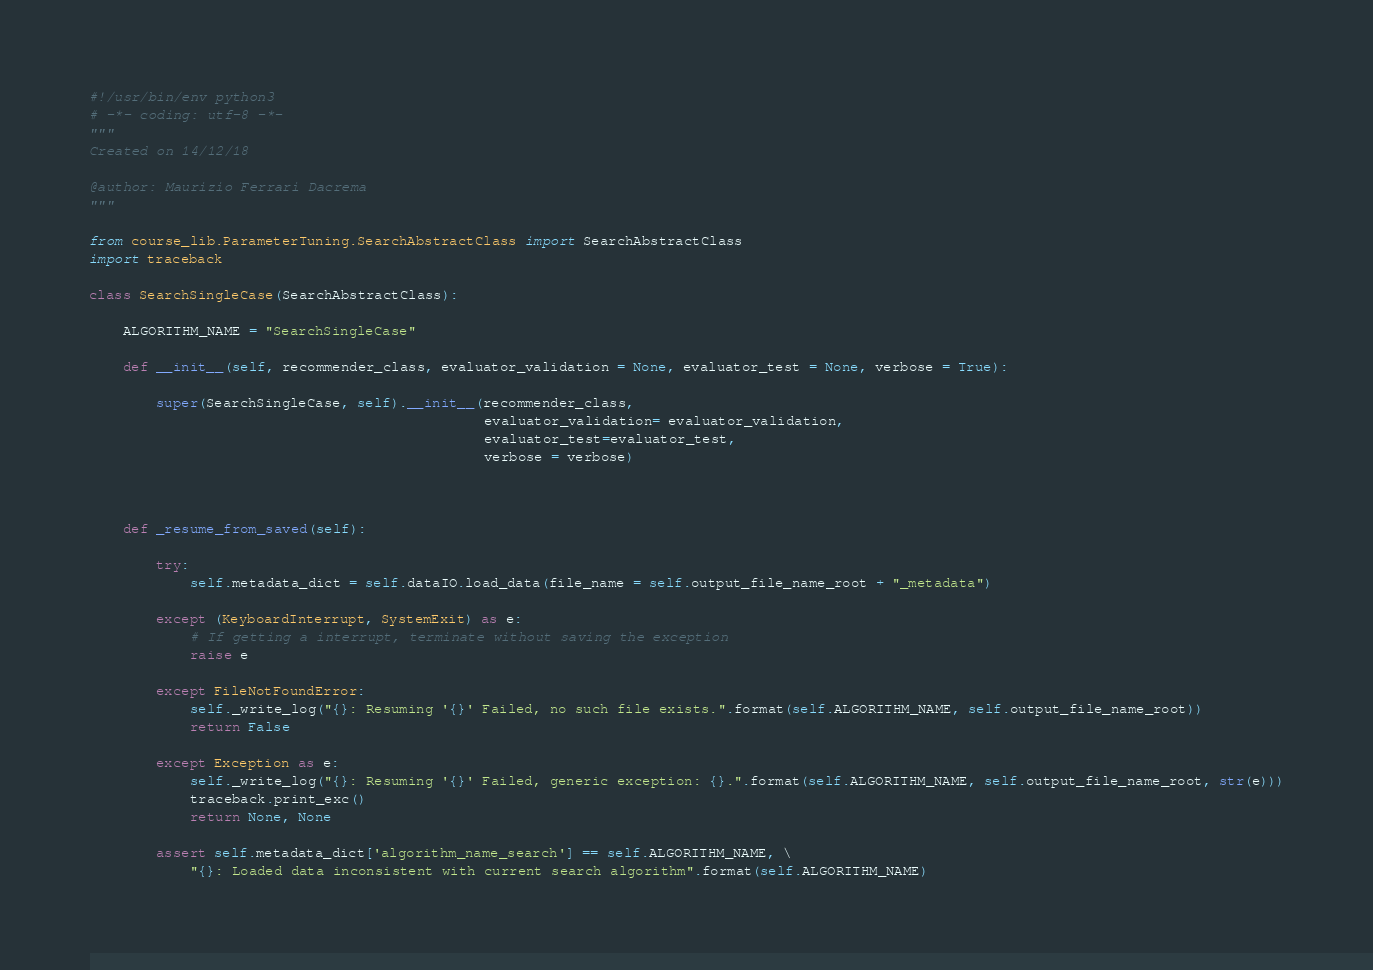<code> <loc_0><loc_0><loc_500><loc_500><_Python_>#!/usr/bin/env python3
# -*- coding: utf-8 -*-
"""
Created on 14/12/18

@author: Maurizio Ferrari Dacrema
"""

from course_lib.ParameterTuning.SearchAbstractClass import SearchAbstractClass
import traceback

class SearchSingleCase(SearchAbstractClass):

    ALGORITHM_NAME = "SearchSingleCase"

    def __init__(self, recommender_class, evaluator_validation = None, evaluator_test = None, verbose = True):

        super(SearchSingleCase, self).__init__(recommender_class,
                                               evaluator_validation= evaluator_validation,
                                               evaluator_test=evaluator_test,
                                               verbose = verbose)



    def _resume_from_saved(self):

        try:
            self.metadata_dict = self.dataIO.load_data(file_name = self.output_file_name_root + "_metadata")

        except (KeyboardInterrupt, SystemExit) as e:
            # If getting a interrupt, terminate without saving the exception
            raise e

        except FileNotFoundError:
            self._write_log("{}: Resuming '{}' Failed, no such file exists.".format(self.ALGORITHM_NAME, self.output_file_name_root))
            return False

        except Exception as e:
            self._write_log("{}: Resuming '{}' Failed, generic exception: {}.".format(self.ALGORITHM_NAME, self.output_file_name_root, str(e)))
            traceback.print_exc()
            return None, None

        assert self.metadata_dict['algorithm_name_search'] == self.ALGORITHM_NAME, \
            "{}: Loaded data inconsistent with current search algorithm".format(self.ALGORITHM_NAME)
</code> 